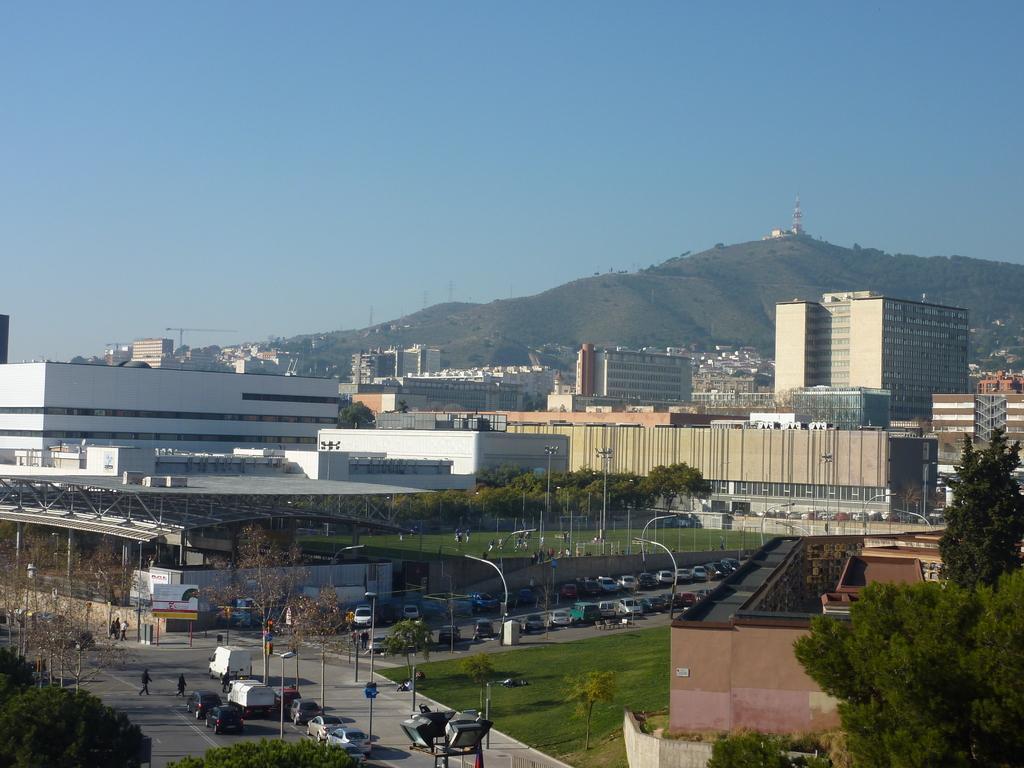In one or two sentences, can you explain what this image depicts? In this image we can see a few buildings, there are some trees, vehicles, poles, lights, windows, people and mountains, in the background we can see the sky. 